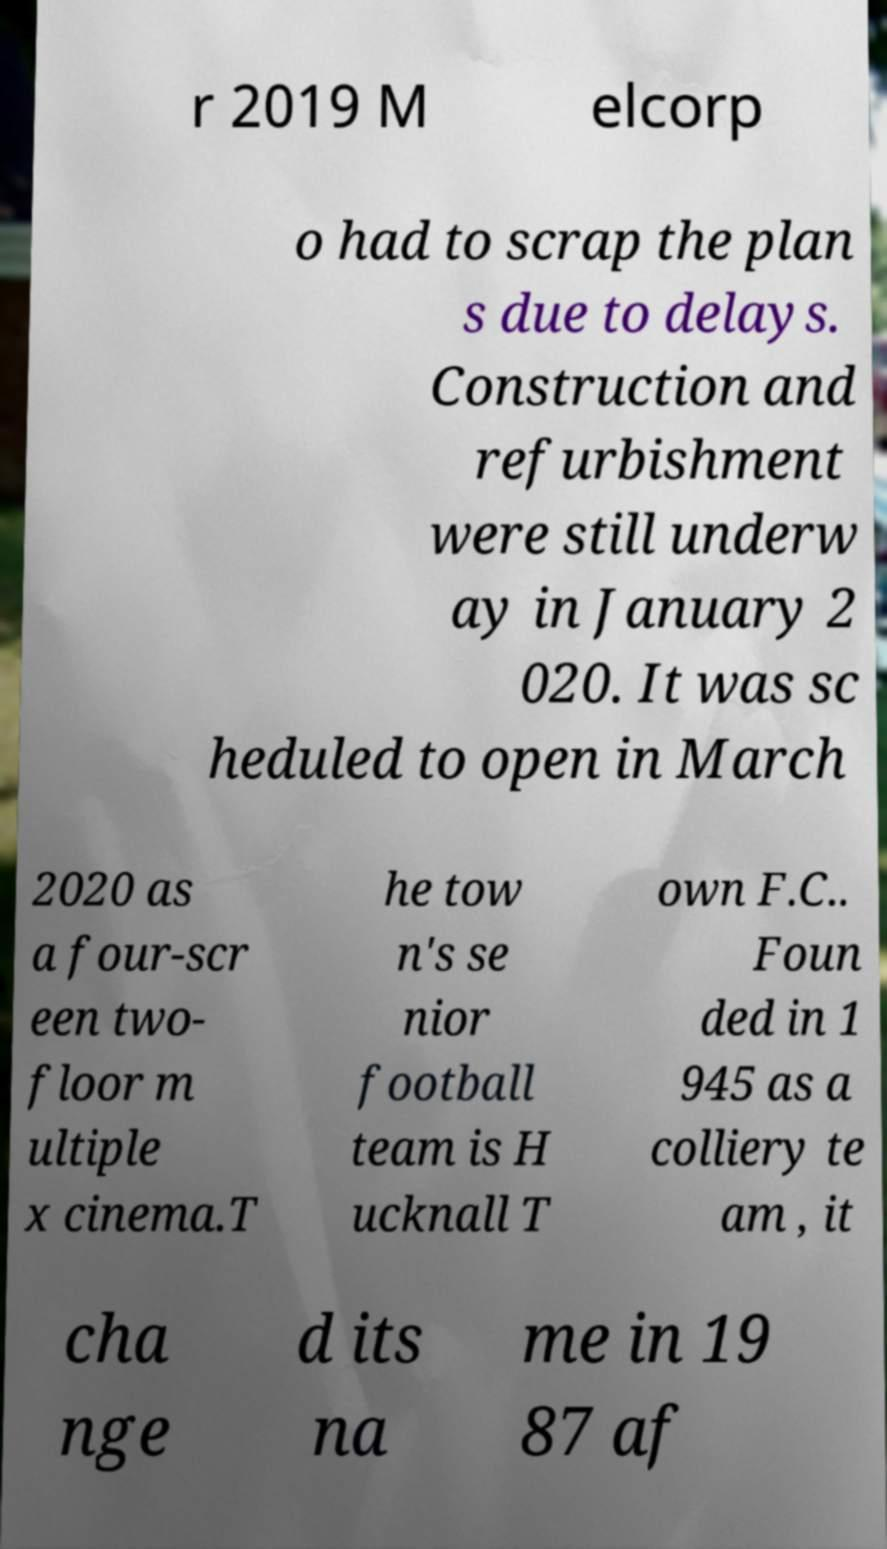Can you accurately transcribe the text from the provided image for me? r 2019 M elcorp o had to scrap the plan s due to delays. Construction and refurbishment were still underw ay in January 2 020. It was sc heduled to open in March 2020 as a four-scr een two- floor m ultiple x cinema.T he tow n's se nior football team is H ucknall T own F.C.. Foun ded in 1 945 as a colliery te am , it cha nge d its na me in 19 87 af 